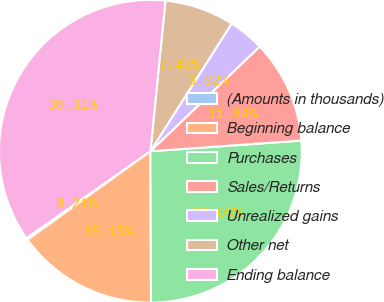Convert chart to OTSL. <chart><loc_0><loc_0><loc_500><loc_500><pie_chart><fcel>(Amounts in thousands)<fcel>Beginning balance<fcel>Purchases<fcel>Sales/Returns<fcel>Unrealized gains<fcel>Other net<fcel>Ending balance<nl><fcel>0.21%<fcel>15.13%<fcel>26.06%<fcel>11.04%<fcel>3.82%<fcel>7.43%<fcel>36.31%<nl></chart> 